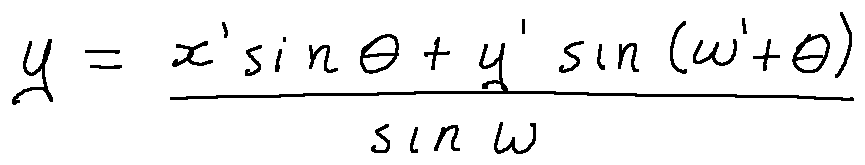Convert formula to latex. <formula><loc_0><loc_0><loc_500><loc_500>y = \frac { x \prime \sin \theta + y \prime \sin ( w \prime + \theta ) } { \sin w }</formula> 